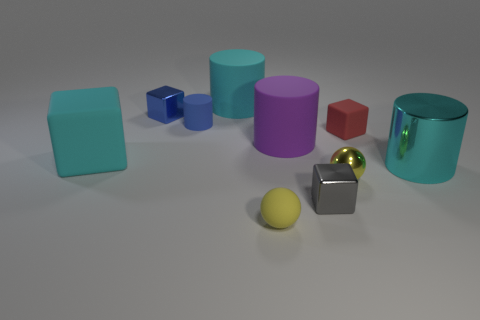Subtract all blue blocks. How many blocks are left? 3 Subtract all brown cubes. How many cyan cylinders are left? 2 Subtract all blue cubes. How many cubes are left? 3 Subtract all blocks. How many objects are left? 6 Subtract all cyan cubes. Subtract all gray balls. How many cubes are left? 3 Subtract 0 purple cubes. How many objects are left? 10 Subtract all big blue shiny blocks. Subtract all cyan matte cubes. How many objects are left? 9 Add 8 small yellow shiny spheres. How many small yellow shiny spheres are left? 9 Add 5 big cyan objects. How many big cyan objects exist? 8 